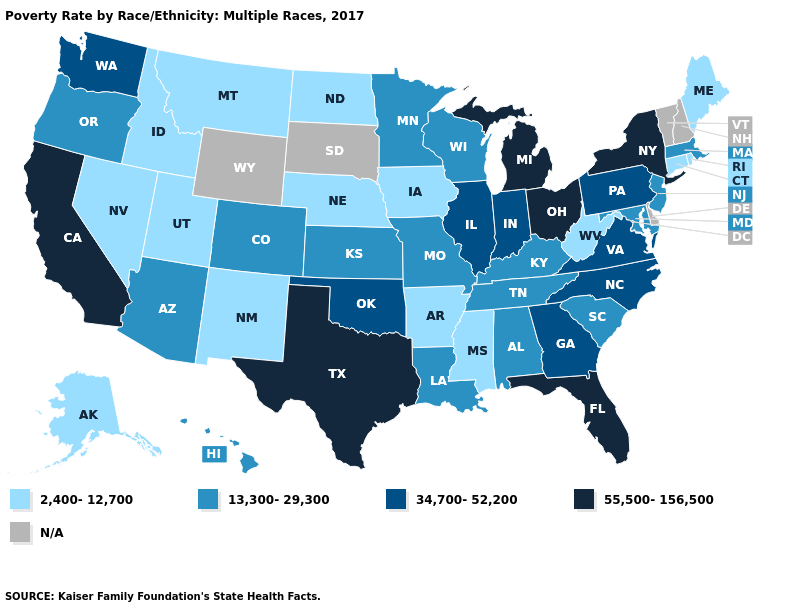Name the states that have a value in the range 13,300-29,300?
Write a very short answer. Alabama, Arizona, Colorado, Hawaii, Kansas, Kentucky, Louisiana, Maryland, Massachusetts, Minnesota, Missouri, New Jersey, Oregon, South Carolina, Tennessee, Wisconsin. Name the states that have a value in the range 13,300-29,300?
Short answer required. Alabama, Arizona, Colorado, Hawaii, Kansas, Kentucky, Louisiana, Maryland, Massachusetts, Minnesota, Missouri, New Jersey, Oregon, South Carolina, Tennessee, Wisconsin. Is the legend a continuous bar?
Answer briefly. No. Among the states that border Utah , which have the highest value?
Keep it brief. Arizona, Colorado. Name the states that have a value in the range 13,300-29,300?
Be succinct. Alabama, Arizona, Colorado, Hawaii, Kansas, Kentucky, Louisiana, Maryland, Massachusetts, Minnesota, Missouri, New Jersey, Oregon, South Carolina, Tennessee, Wisconsin. What is the value of Kentucky?
Quick response, please. 13,300-29,300. What is the highest value in the USA?
Keep it brief. 55,500-156,500. Name the states that have a value in the range 13,300-29,300?
Be succinct. Alabama, Arizona, Colorado, Hawaii, Kansas, Kentucky, Louisiana, Maryland, Massachusetts, Minnesota, Missouri, New Jersey, Oregon, South Carolina, Tennessee, Wisconsin. Which states have the lowest value in the USA?
Be succinct. Alaska, Arkansas, Connecticut, Idaho, Iowa, Maine, Mississippi, Montana, Nebraska, Nevada, New Mexico, North Dakota, Rhode Island, Utah, West Virginia. Name the states that have a value in the range 34,700-52,200?
Quick response, please. Georgia, Illinois, Indiana, North Carolina, Oklahoma, Pennsylvania, Virginia, Washington. What is the value of Tennessee?
Short answer required. 13,300-29,300. What is the value of North Dakota?
Answer briefly. 2,400-12,700. Among the states that border Maryland , which have the highest value?
Concise answer only. Pennsylvania, Virginia. Does Nebraska have the lowest value in the MidWest?
Give a very brief answer. Yes. 